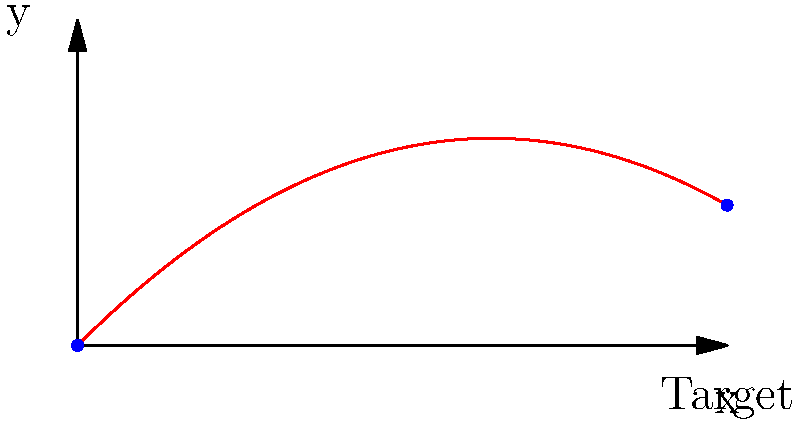Calculate the initial velocity $v_0$ needed to hit a target 200 meters away, given that the object is thrown at a 45-degree angle from the ground. Assume no air resistance and use $g = 9.8$ m/s² for acceleration due to gravity. Round your answer to the nearest whole number. To solve this problem, we'll use the equation for the range of a projectile:

1) The range equation: $R = \frac{v_0^2 \sin(2\theta)}{g}$

2) We know:
   $R = 200$ m (target distance)
   $\theta = 45°$ (angle of projection)
   $g = 9.8$ m/s²

3) Substitute $\theta = 45°$:
   $\sin(2 \cdot 45°) = \sin(90°) = 1$

4) Plug in the known values:
   $200 = \frac{v_0^2 \cdot 1}{9.8}$

5) Solve for $v_0$:
   $v_0^2 = 200 \cdot 9.8 = 1960$
   $v_0 = \sqrt{1960} \approx 44.27$ m/s

6) Rounding to the nearest whole number:
   $v_0 \approx 44$ m/s

Therefore, the initial velocity needed is approximately 44 m/s.
Answer: 44 m/s 